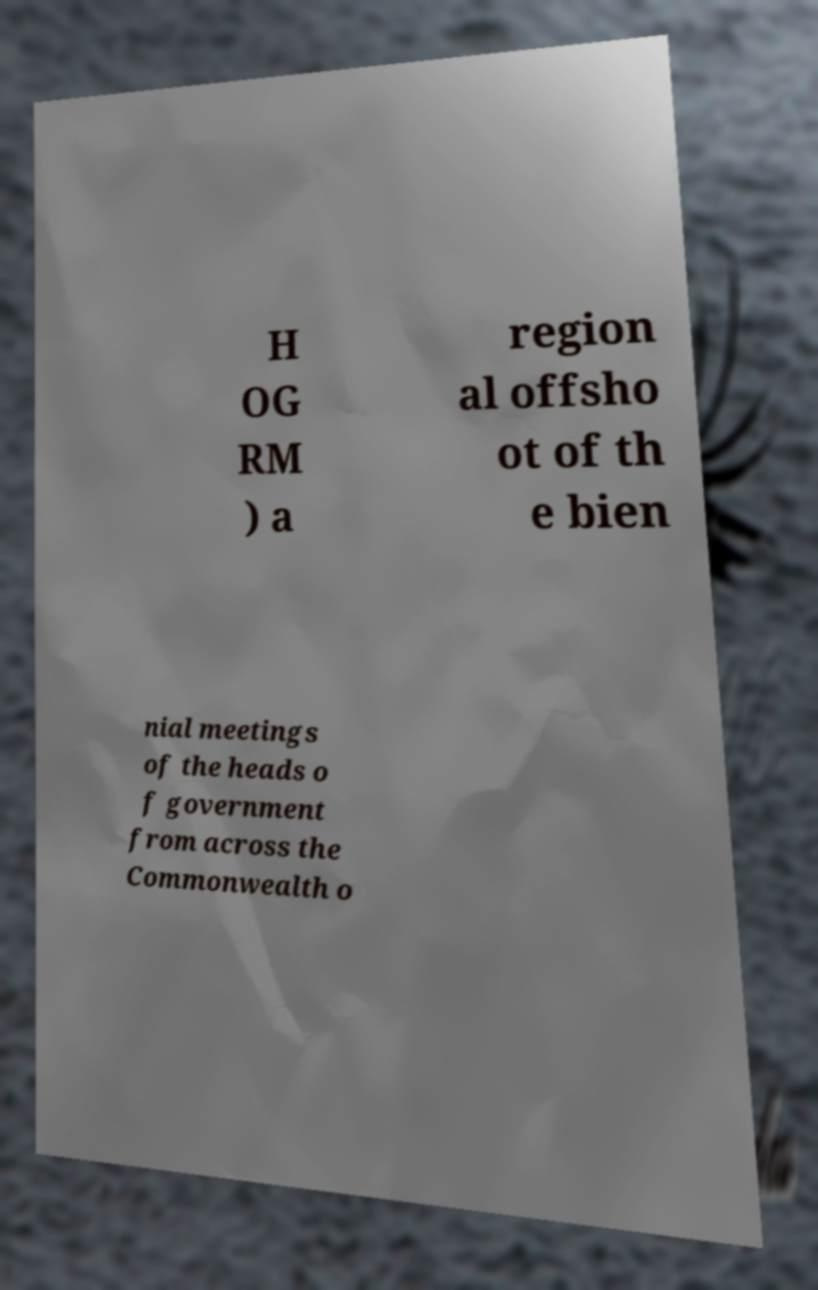Could you assist in decoding the text presented in this image and type it out clearly? H OG RM ) a region al offsho ot of th e bien nial meetings of the heads o f government from across the Commonwealth o 